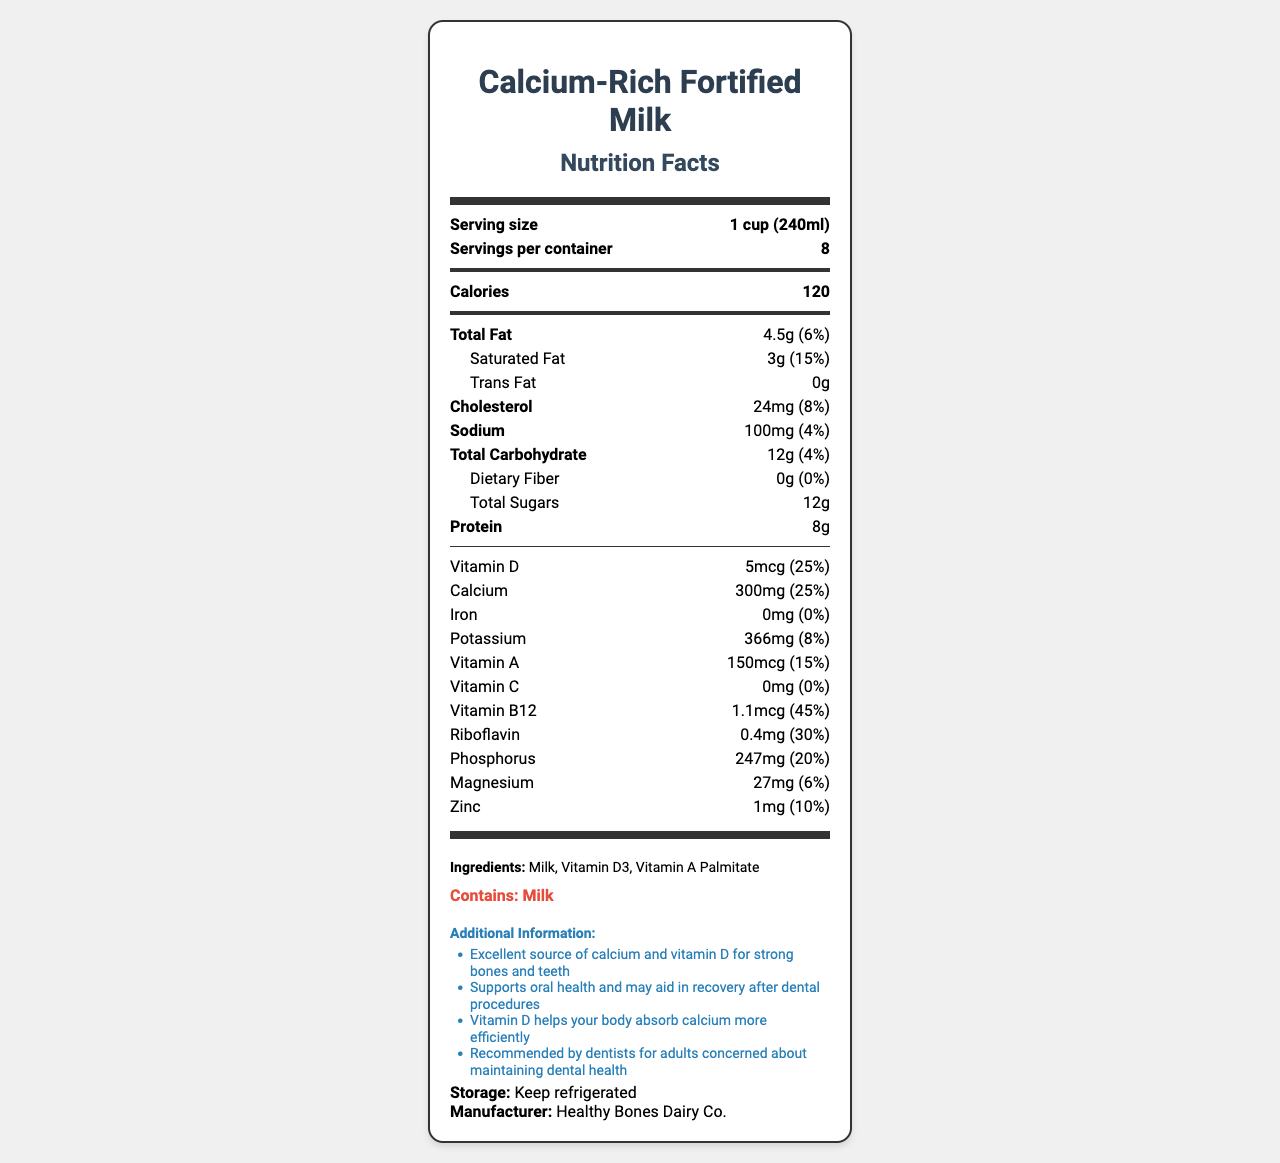What is the serving size of the Calcium-Rich Fortified Milk? The label indicates that the serving size is 1 cup (240ml).
Answer: 1 cup (240ml) How many calories are in one serving of this product? The label shows that each serving contains 120 calories.
Answer: 120 What percentage of the daily value of vitamin D does one serving provide? According to the label, one serving provides 25% of the daily value of vitamin D.
Answer: 25% What are the primary ingredients in this product? The label lists Milk, Vitamin D3, and Vitamin A Palmitate as the primary ingredients.
Answer: Milk, Vitamin D3, Vitamin A Palmitate Which nutrient has a daily value percentage of 45%? The daily value percentage of Vitamin B12 is listed as 45%.
Answer: Vitamin B12 How much calcium is in one serving? The label shows that there are 300mg of calcium in one serving.
Answer: 300mg What is the total fat content per serving? The total fat content per serving is listed as 4.5g on the label.
Answer: 4.5g Which of the following best describes the sodium content in one serving? A. 100mg B. 150mg C. 200mg D. 50mg The label indicates that one serving contains 100mg of sodium.
Answer: A. 100mg What percentage of the daily value of saturated fat does one serving provide? A. 5% B. 10% C. 15% D. 20% The label states that one serving provides 15% of the daily value of saturated fat.
Answer: C. 15% Does this product contain any dietary fiber? The label indicates 0g of dietary fiber per serving.
Answer: No Is this product recommended for adults concerned about maintaining dental health? The additional information specifies that the product is recommended by dentists for adults concerned about dental health.
Answer: Yes Are there any allergens in this product? The label explicitly states "Contains: Milk," indicating that milk is an allergen present in the product.
Answer: Yes Summarize the main nutritional benefits of Calcium-Rich Fortified Milk. The document highlights that the product is fortified with vitamin D to aid calcium absorption and is beneficial for dental health, providing significant percentages of daily values for several nutrients, particularly calcium and vitamin D.
Answer: The product is an excellent source of calcium and vitamin D, which are essential for strong bones and teeth. It supports oral health and may aid in recovery after dental procedures. It is recommended by dentists for adults concerned about maintaining dental health. Who manufactures this product? The label specifies that the product is manufactured by Healthy Bones Dairy Co.
Answer: Healthy Bones Dairy Co. Can this product be used to treat vitamin deficiency? The label provides nutritional information but does not explicitly state whether the product can be used to treat vitamin deficiencies.
Answer: Not enough information 